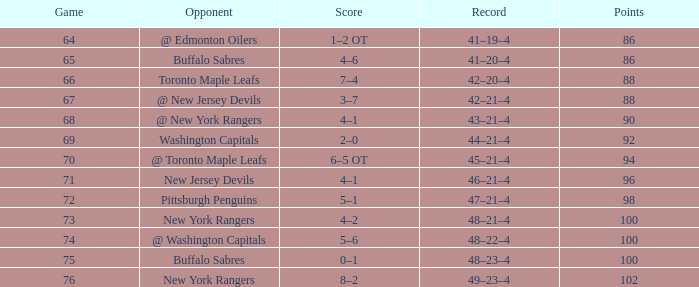Which Score has a March larger than 15, and Points larger than 96, and a Game smaller than 76, and an Opponent of @ washington capitals? 5–6. 